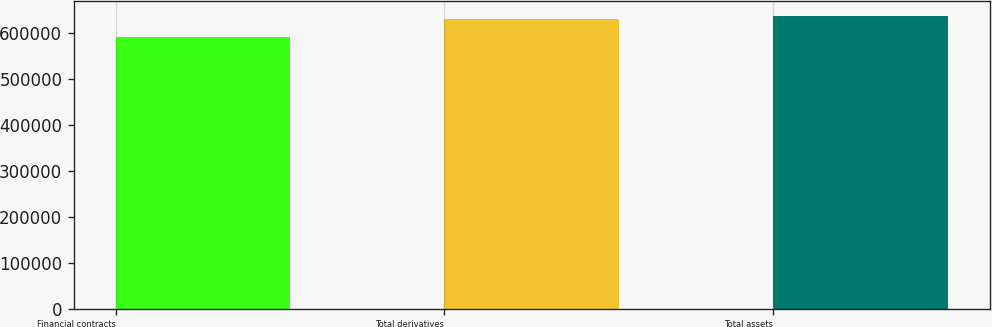Convert chart. <chart><loc_0><loc_0><loc_500><loc_500><bar_chart><fcel>Financial contracts<fcel>Total derivatives<fcel>Total assets<nl><fcel>592052<fcel>630847<fcel>638545<nl></chart> 